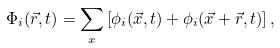<formula> <loc_0><loc_0><loc_500><loc_500>\Phi _ { i } ( \vec { r } , t ) = \sum _ { x } \left [ \phi _ { i } ( \vec { x } , t ) + \phi _ { i } ( \vec { x } + \vec { r } , t ) \right ] ,</formula> 